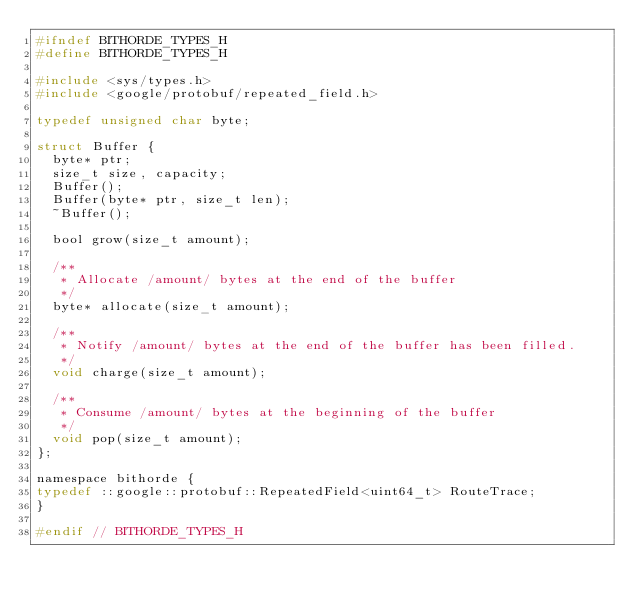<code> <loc_0><loc_0><loc_500><loc_500><_C_>#ifndef BITHORDE_TYPES_H
#define BITHORDE_TYPES_H

#include <sys/types.h>
#include <google/protobuf/repeated_field.h>

typedef unsigned char byte;

struct Buffer {
	byte* ptr;
	size_t size, capacity;
	Buffer();
	Buffer(byte* ptr, size_t len);
	~Buffer();

	bool grow(size_t amount);

	/**
	 * Allocate /amount/ bytes at the end of the buffer
	 */
	byte* allocate(size_t amount);

	/**
	 * Notify /amount/ bytes at the end of the buffer has been filled.
	 */
	void charge(size_t amount);

	/**
	 * Consume /amount/ bytes at the beginning of the buffer
	 */
	void pop(size_t amount);
};

namespace bithorde {
typedef ::google::protobuf::RepeatedField<uint64_t> RouteTrace;
}

#endif // BITHORDE_TYPES_H
</code> 